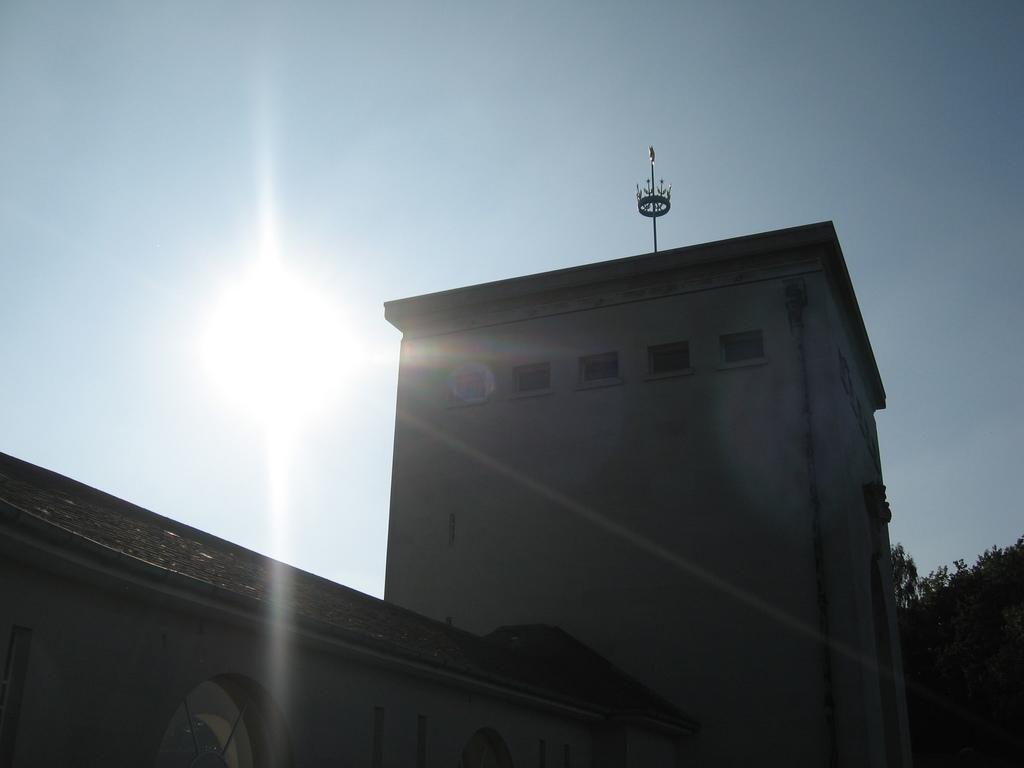In one or two sentences, can you explain what this image depicts? In this picture there is a building on the right side of the image and there are trees on the right side of the image, there are windows on the building, in the center of the image and there are glass doors at the bottom side of the image. 